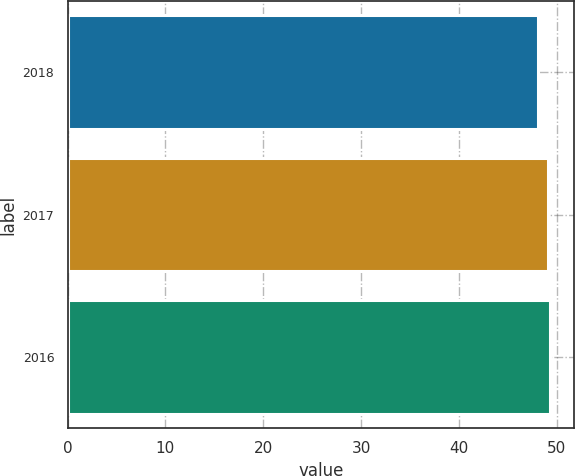Convert chart. <chart><loc_0><loc_0><loc_500><loc_500><bar_chart><fcel>2018<fcel>2017<fcel>2016<nl><fcel>48.1<fcel>49.1<fcel>49.3<nl></chart> 